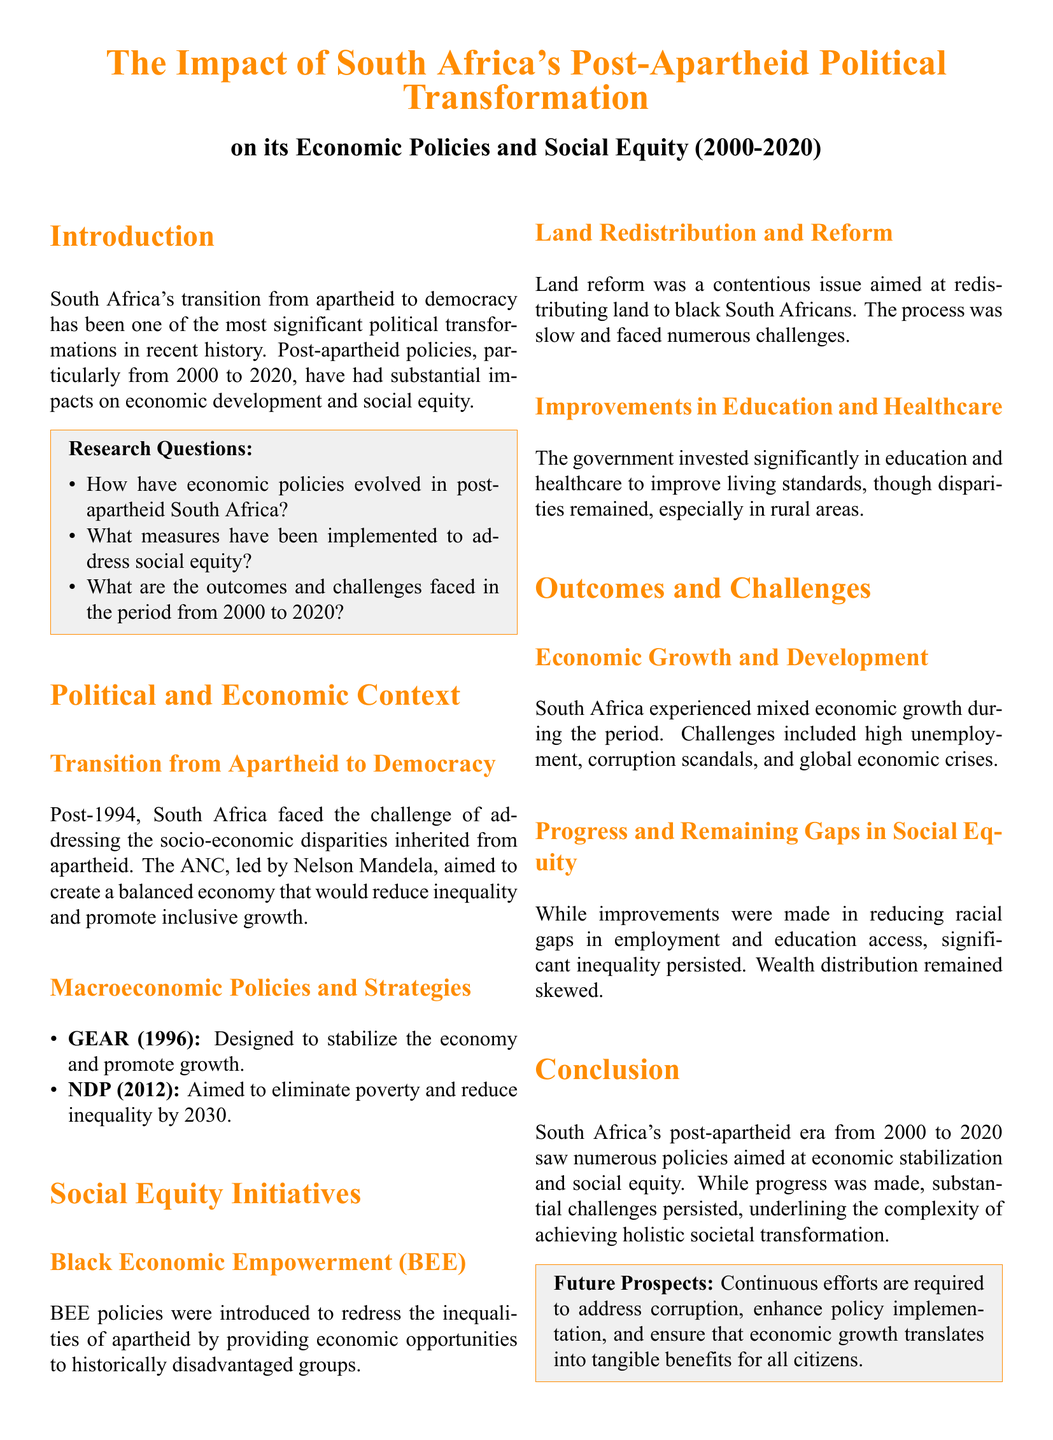What are the main economic strategies introduced in post-apartheid South Africa? The document lists GEAR (1996) and NDP (2012) as the main economic strategies.
Answer: GEAR and NDP What was the aim of the NDP? The NDP aimed to eliminate poverty and reduce inequality by 2030, according to the document.
Answer: Eliminate poverty and reduce inequality by 2030 What initiative was established to address apartheid inequalities? The Black Economic Empowerment (BEE) initiative was introduced to provide economic opportunities to historically disadvantaged groups.
Answer: Black Economic Empowerment (BEE) What was a significant challenge in land reform? The document mentions that the land redistribution process was slow and faced numerous challenges.
Answer: Slow and faced numerous challenges How did the government invest in social equity? The government invested significantly in education and healthcare to improve living standards.
Answer: Education and healthcare What was a notable outcome in employment during this period? The document indicates that while improvements were made, significant inequality persisted in employment.
Answer: Significant inequality persisted What major issue impacted South Africa's economic growth? Corruption scandals were one of the challenges that impacted economic growth.
Answer: Corruption scandals What is stated as necessary for future prospects in South Africa? The document stresses that continuous efforts are required to address corruption and enhance policy implementation.
Answer: Address corruption and enhance policy implementation What was a significant aspect of improvements noted in the document? The document states that there were improvements in reducing racial gaps in education access.
Answer: Reducing racial gaps in education access 